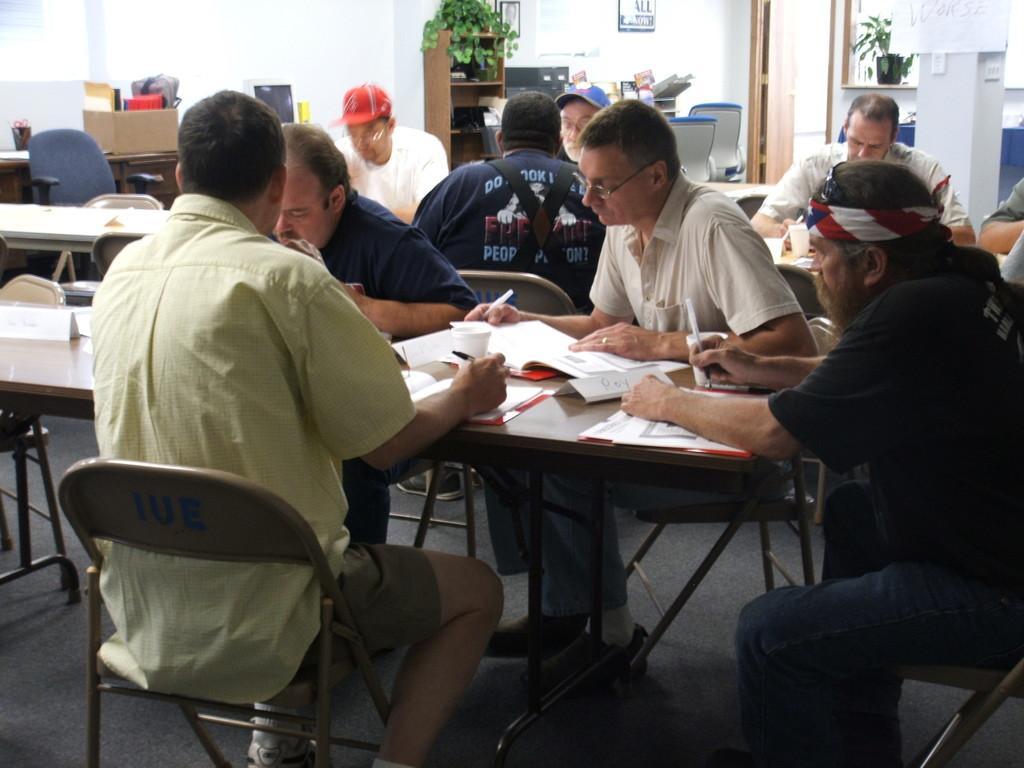How would you summarize this image in a sentence or two? This is a picture in a library or a office. In the foreground of the picture there are four people sitting in chairs around a table, on the table there are books and a name plate. In the background there are many other people sitting on tables. On the top of left there is a box. In the center of the background there is a closet books and a houseplant. On the top right there is a house plant and a door. In the background to the wall there is a frame. 